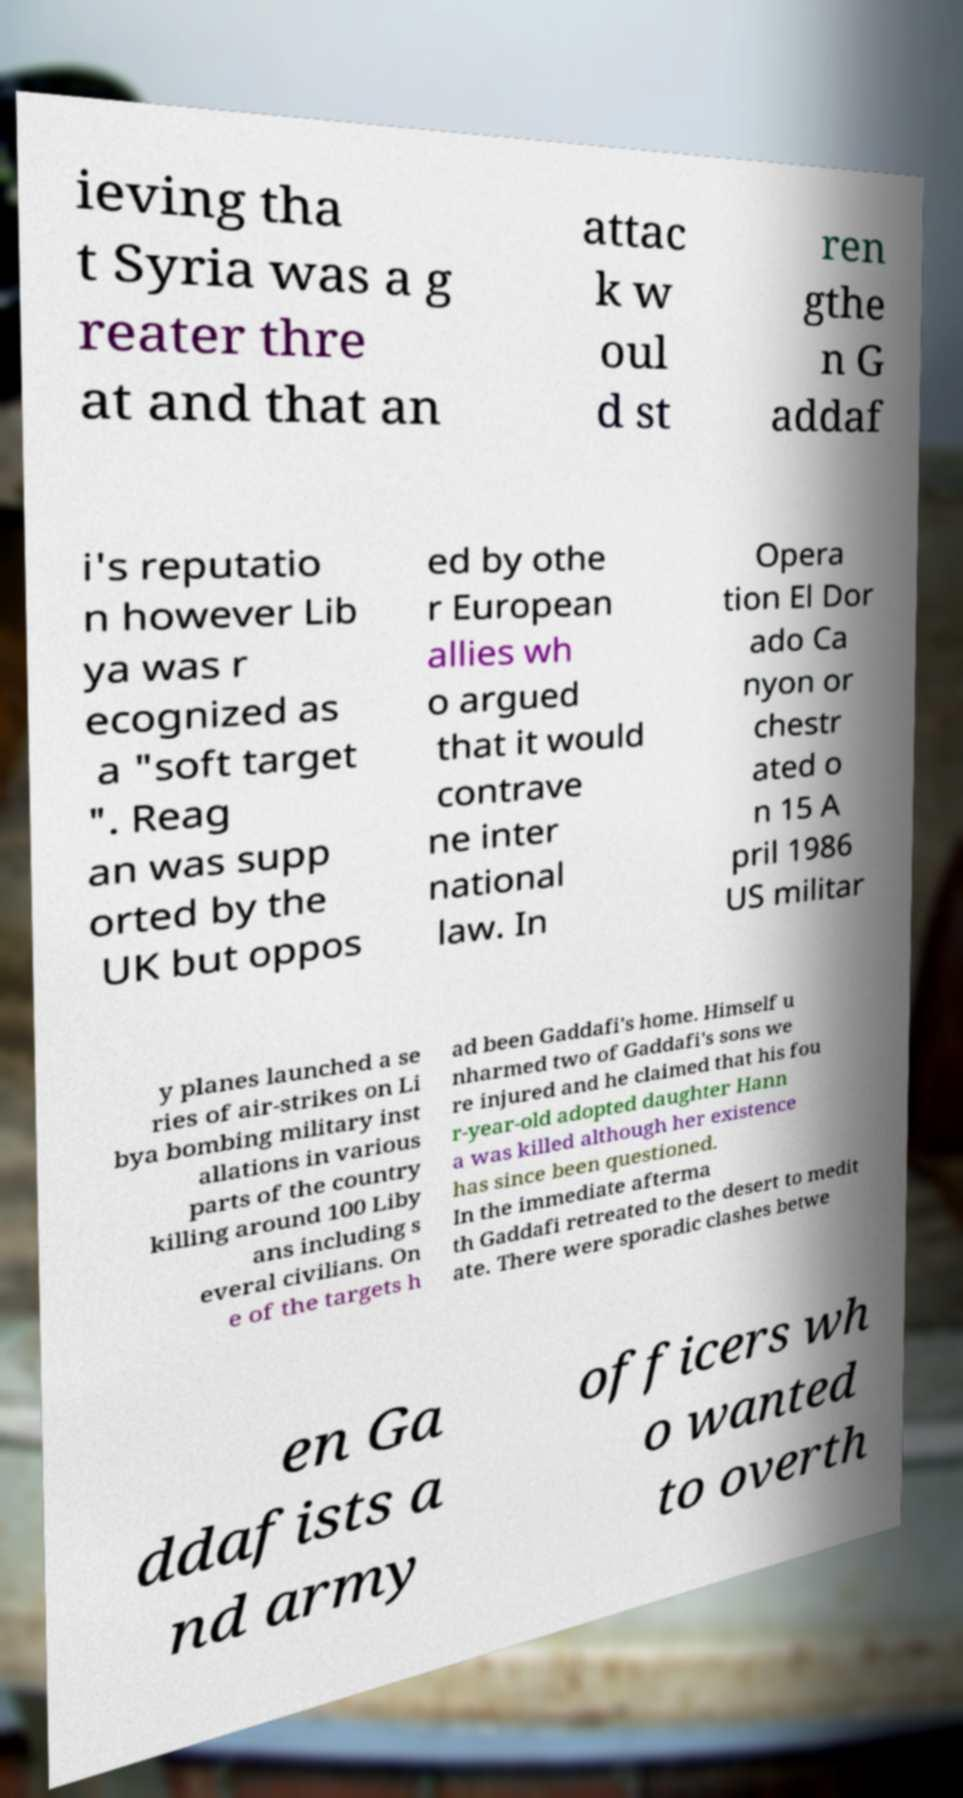Please read and relay the text visible in this image. What does it say? ieving tha t Syria was a g reater thre at and that an attac k w oul d st ren gthe n G addaf i's reputatio n however Lib ya was r ecognized as a "soft target ". Reag an was supp orted by the UK but oppos ed by othe r European allies wh o argued that it would contrave ne inter national law. In Opera tion El Dor ado Ca nyon or chestr ated o n 15 A pril 1986 US militar y planes launched a se ries of air-strikes on Li bya bombing military inst allations in various parts of the country killing around 100 Liby ans including s everal civilians. On e of the targets h ad been Gaddafi's home. Himself u nharmed two of Gaddafi's sons we re injured and he claimed that his fou r-year-old adopted daughter Hann a was killed although her existence has since been questioned. In the immediate afterma th Gaddafi retreated to the desert to medit ate. There were sporadic clashes betwe en Ga ddafists a nd army officers wh o wanted to overth 